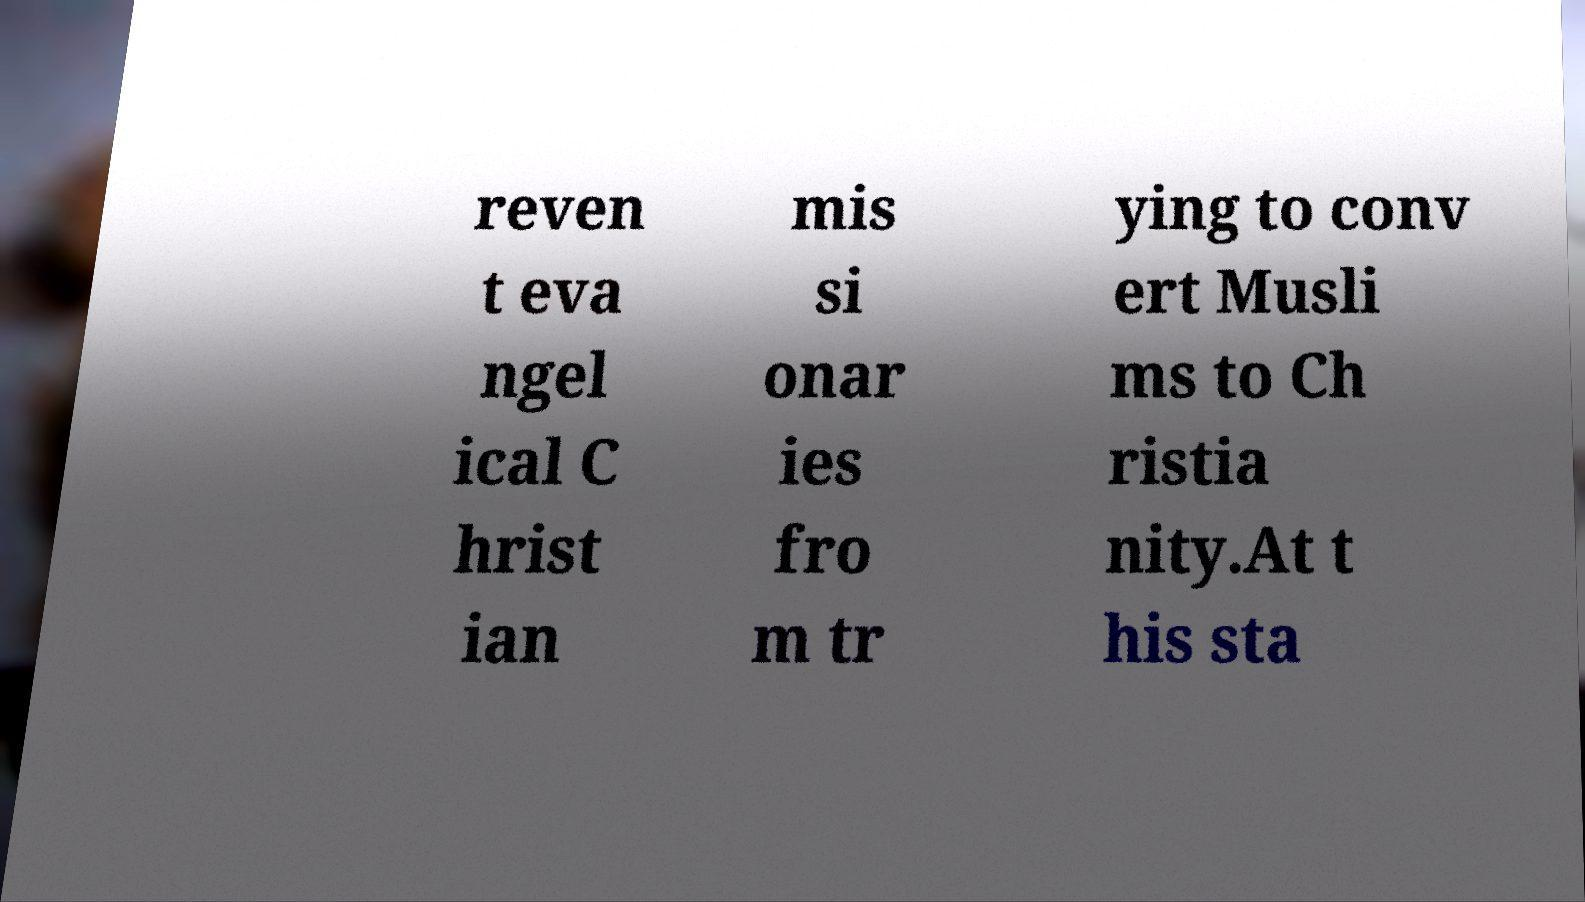Could you extract and type out the text from this image? reven t eva ngel ical C hrist ian mis si onar ies fro m tr ying to conv ert Musli ms to Ch ristia nity.At t his sta 